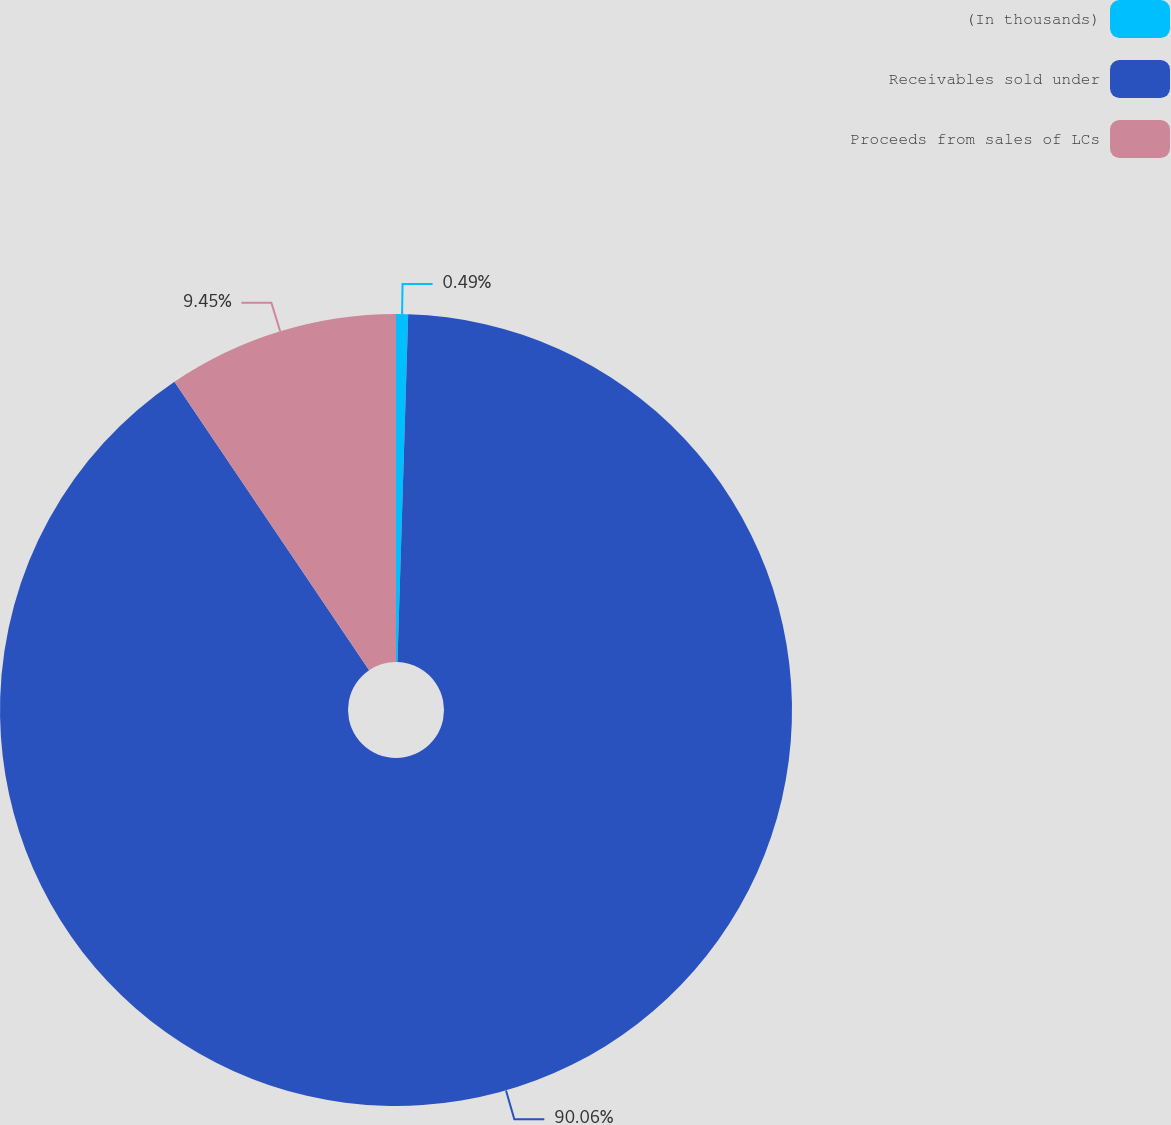<chart> <loc_0><loc_0><loc_500><loc_500><pie_chart><fcel>(In thousands)<fcel>Receivables sold under<fcel>Proceeds from sales of LCs<nl><fcel>0.49%<fcel>90.06%<fcel>9.45%<nl></chart> 